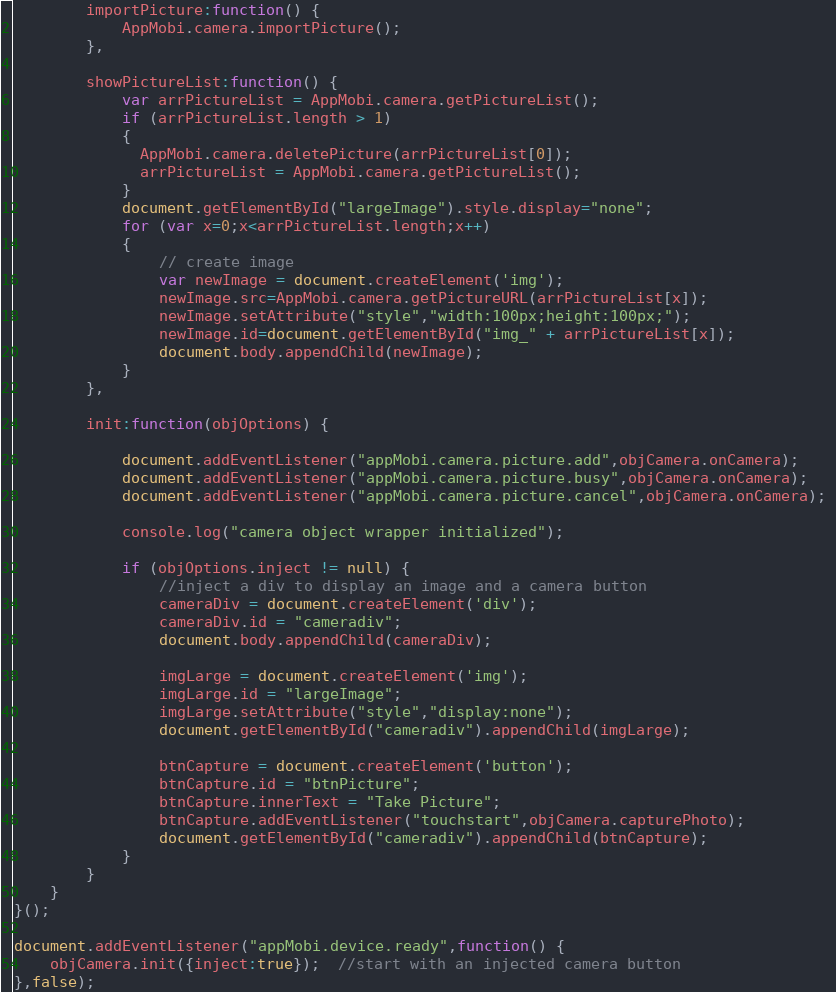<code> <loc_0><loc_0><loc_500><loc_500><_JavaScript_>		importPicture:function() {
			AppMobi.camera.importPicture();	
		},
		
		showPictureList:function() {
			var arrPictureList = AppMobi.camera.getPictureList();
			if (arrPictureList.length > 1)
			{
			  AppMobi.camera.deletePicture(arrPictureList[0]);
			  arrPictureList = AppMobi.camera.getPictureList();
			}
			document.getElementById("largeImage").style.display="none";
			for (var x=0;x<arrPictureList.length;x++)
			{
				// create image 
				var newImage = document.createElement('img');
				newImage.src=AppMobi.camera.getPictureURL(arrPictureList[x]);
				newImage.setAttribute("style","width:100px;height:100px;");
				newImage.id=document.getElementById("img_" + arrPictureList[x]);
				document.body.appendChild(newImage);
			}
		},
		
		init:function(objOptions) {

			document.addEventListener("appMobi.camera.picture.add",objCamera.onCamera); 
			document.addEventListener("appMobi.camera.picture.busy",objCamera.onCamera); 
			document.addEventListener("appMobi.camera.picture.cancel",objCamera.onCamera); 

			console.log("camera object wrapper initialized");

			if (objOptions.inject != null) {
				//inject a div to display an image and a camera button
				cameraDiv = document.createElement('div');
				cameraDiv.id = "cameradiv";
				document.body.appendChild(cameraDiv);

				imgLarge = document.createElement('img');
				imgLarge.id = "largeImage";
				imgLarge.setAttribute("style","display:none");
				document.getElementById("cameradiv").appendChild(imgLarge);

				btnCapture = document.createElement('button');
				btnCapture.id = "btnPicture";
				btnCapture.innerText = "Take Picture";
				btnCapture.addEventListener("touchstart",objCamera.capturePhoto);
				document.getElementById("cameradiv").appendChild(btnCapture);
			}
		}
	}
}();

document.addEventListener("appMobi.device.ready",function() {
	objCamera.init({inject:true});  //start with an injected camera button
},false); 


</code> 